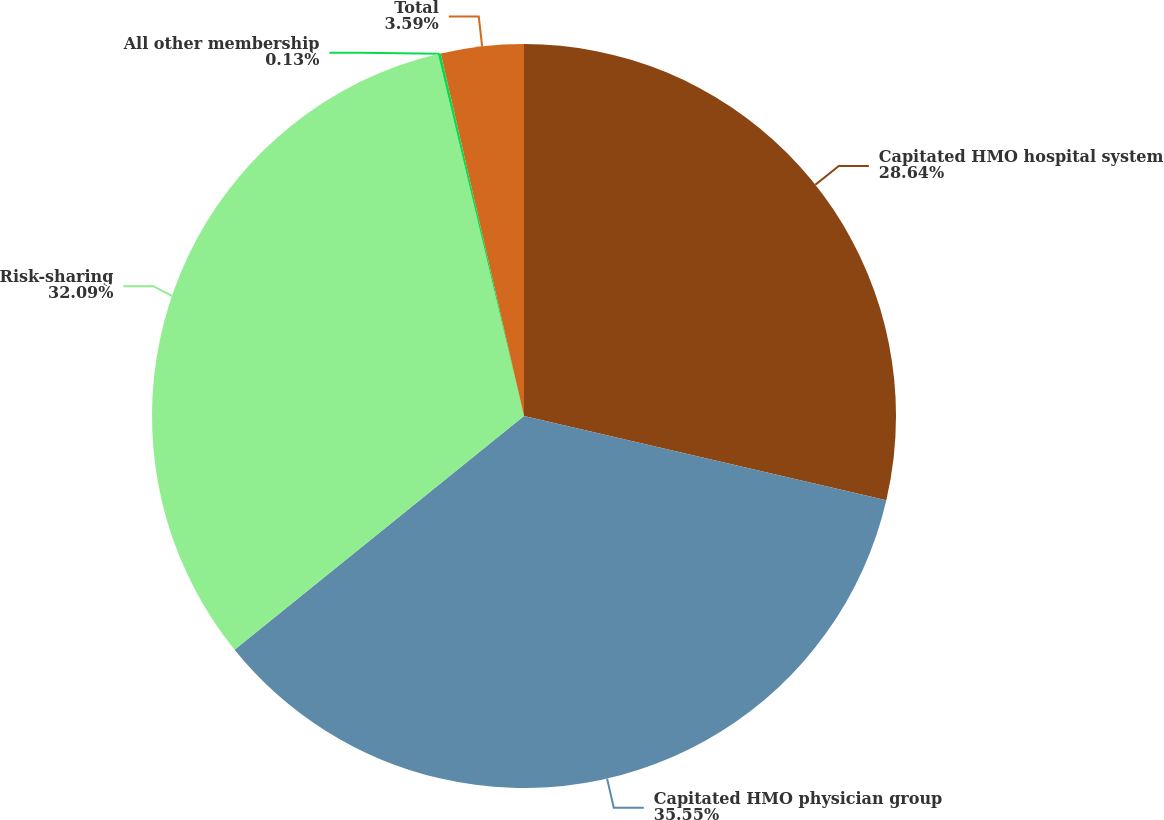Convert chart. <chart><loc_0><loc_0><loc_500><loc_500><pie_chart><fcel>Capitated HMO hospital system<fcel>Capitated HMO physician group<fcel>Risk-sharing<fcel>All other membership<fcel>Total<nl><fcel>28.64%<fcel>35.55%<fcel>32.09%<fcel>0.13%<fcel>3.59%<nl></chart> 